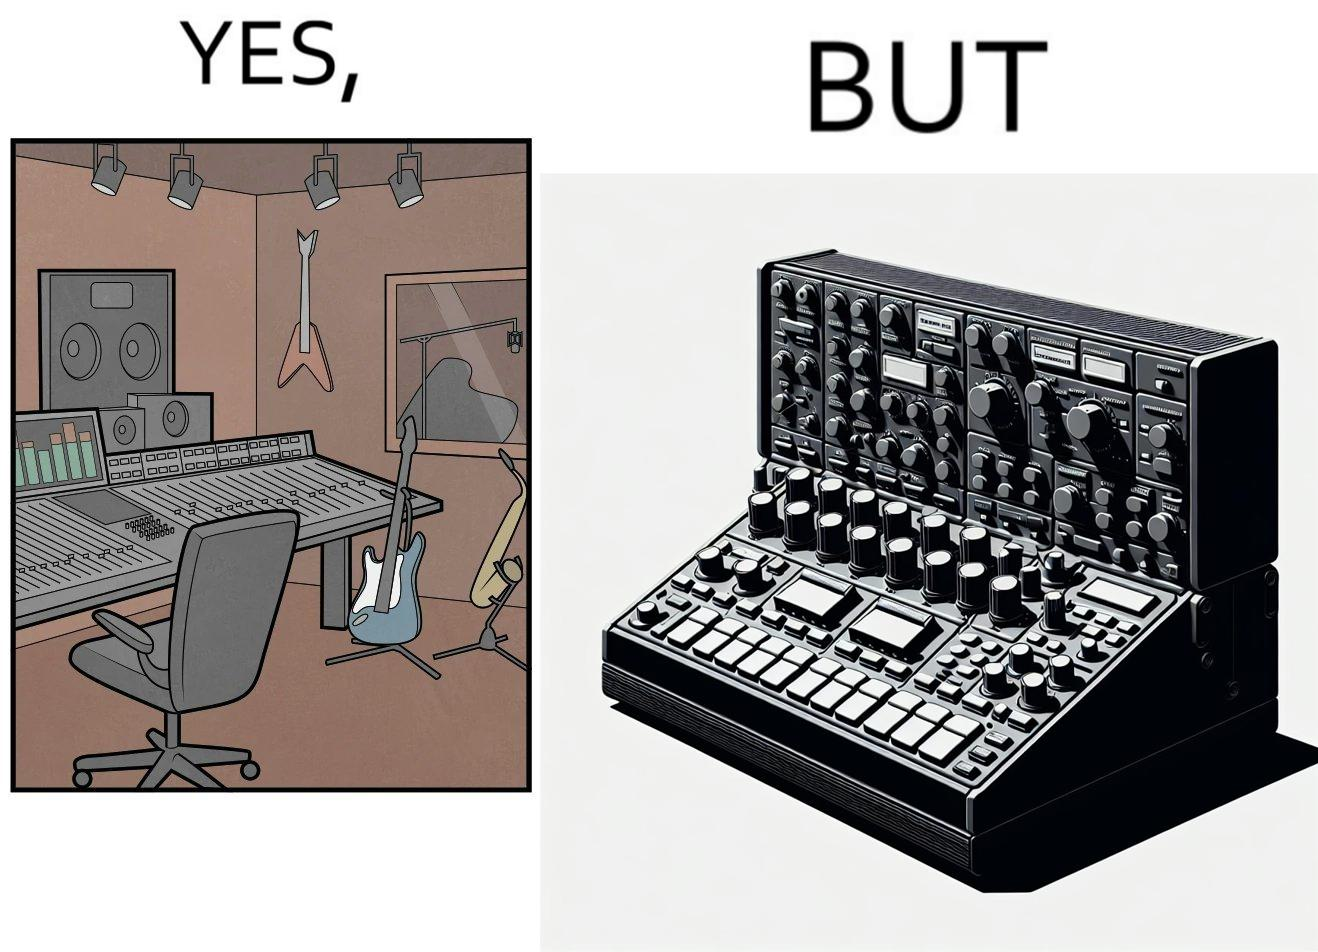Describe what you see in the left and right parts of this image. In the left part of the image: The image shows a music studio with differnt kinds of instruments like guitar and saxophone, piano and recording  to make music. In the right part of the image: The image shows the view of an electornic equipment used to create music. It has buttons to record, play drums and other musical instruments. 